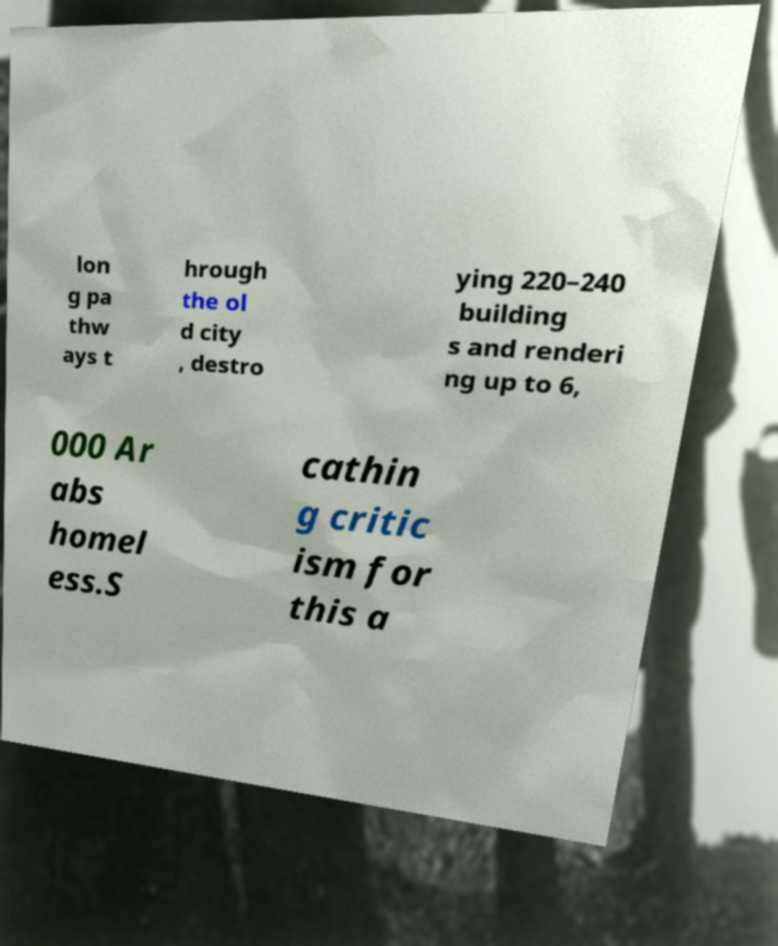Could you assist in decoding the text presented in this image and type it out clearly? lon g pa thw ays t hrough the ol d city , destro ying 220–240 building s and renderi ng up to 6, 000 Ar abs homel ess.S cathin g critic ism for this a 